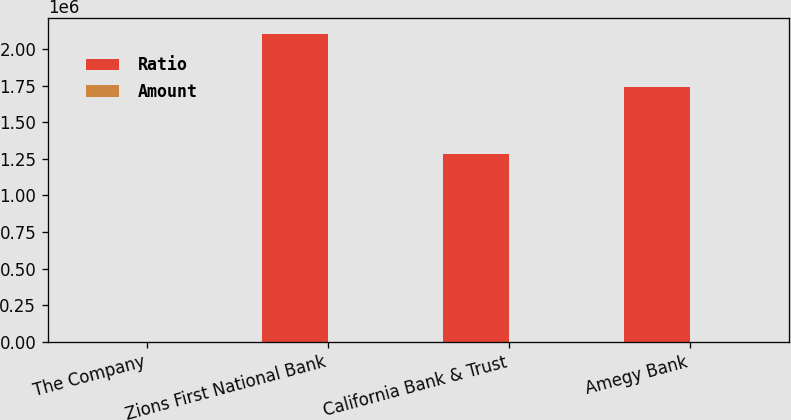Convert chart to OTSL. <chart><loc_0><loc_0><loc_500><loc_500><stacked_bar_chart><ecel><fcel>The Company<fcel>Zions First National Bank<fcel>California Bank & Trust<fcel>Amegy Bank<nl><fcel>Ratio<fcel>16.27<fcel>2.1089e+06<fcel>1.2861e+06<fcel>1.74159e+06<nl><fcel>Amount<fcel>16.27<fcel>15.27<fcel>14.18<fcel>14.09<nl></chart> 